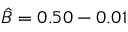Convert formula to latex. <formula><loc_0><loc_0><loc_500><loc_500>\hat { B } = 0 . 5 0 - 0 . 0 1</formula> 